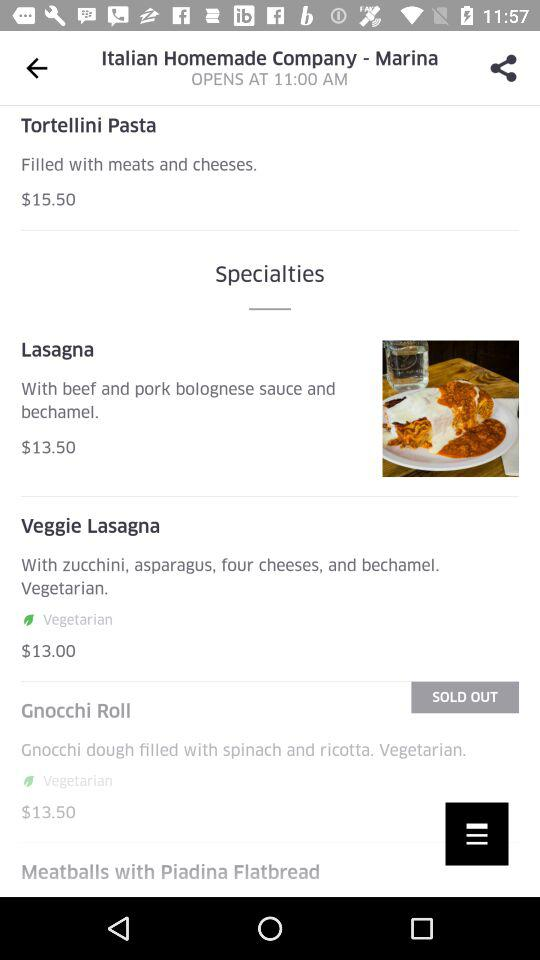What is the opening time of "Italian Homemade Company - Marina"? The opening time is 11:00 AM. 